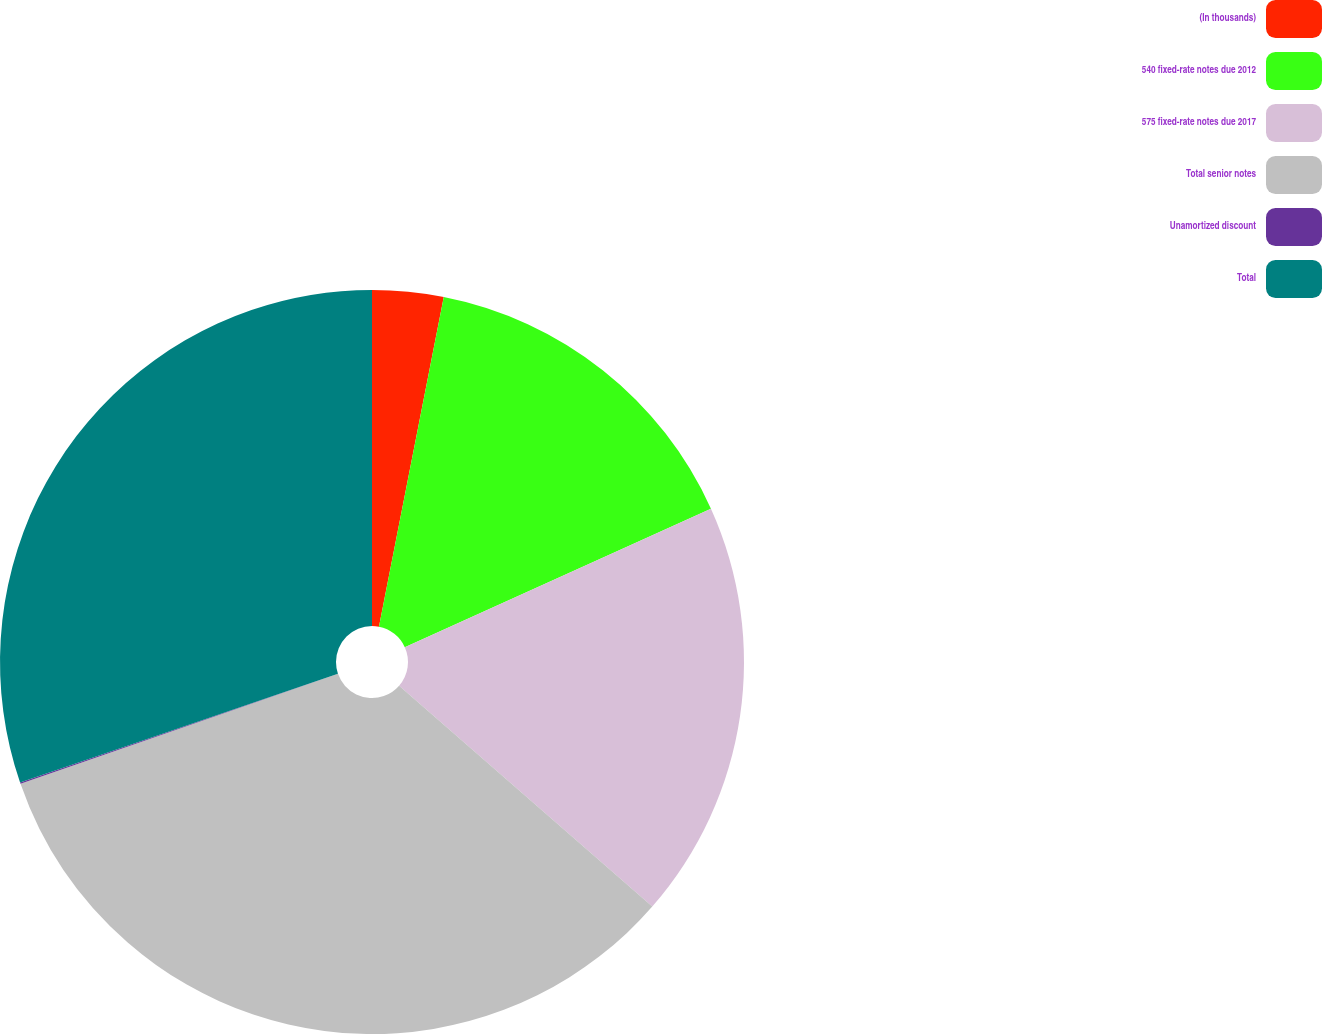Convert chart. <chart><loc_0><loc_0><loc_500><loc_500><pie_chart><fcel>(In thousands)<fcel>540 fixed-rate notes due 2012<fcel>575 fixed-rate notes due 2017<fcel>Total senior notes<fcel>Unamortized discount<fcel>Total<nl><fcel>3.09%<fcel>15.15%<fcel>18.18%<fcel>33.27%<fcel>0.06%<fcel>30.25%<nl></chart> 